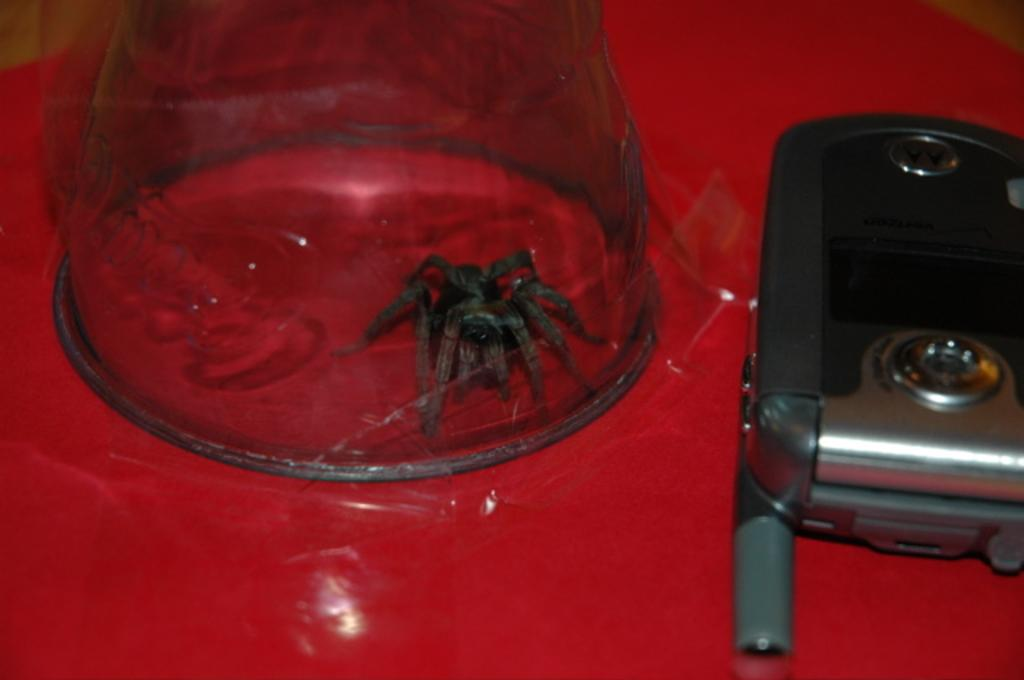What is the main object in the image? There is a mobile in the image. What else can be seen in the image besides the mobile? There is a bowl and an insert underneath the bowl in the image. What type of action is the rabbit performing in the image? There is no rabbit present in the image. 